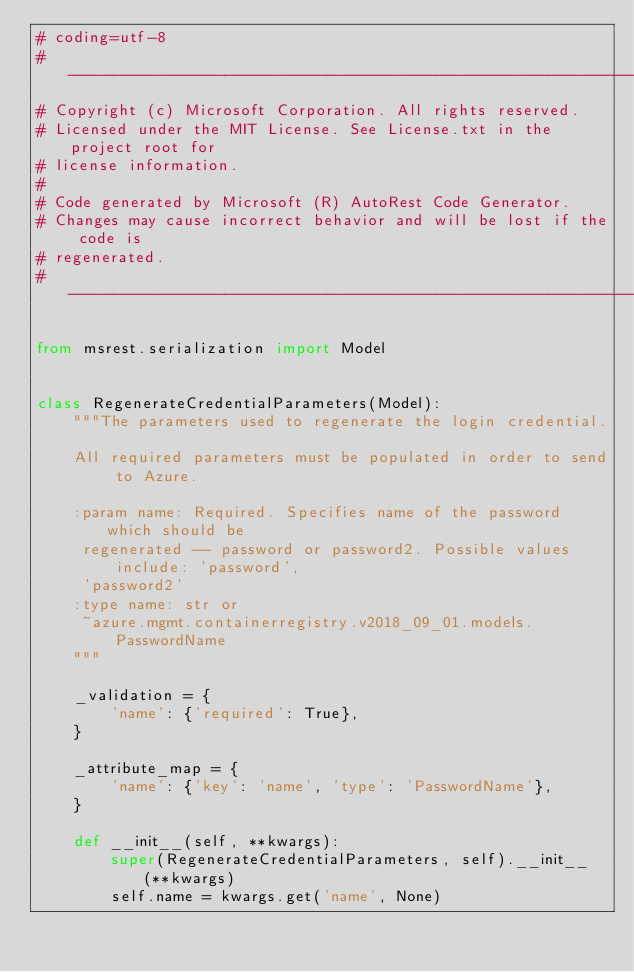<code> <loc_0><loc_0><loc_500><loc_500><_Python_># coding=utf-8
# --------------------------------------------------------------------------
# Copyright (c) Microsoft Corporation. All rights reserved.
# Licensed under the MIT License. See License.txt in the project root for
# license information.
#
# Code generated by Microsoft (R) AutoRest Code Generator.
# Changes may cause incorrect behavior and will be lost if the code is
# regenerated.
# --------------------------------------------------------------------------

from msrest.serialization import Model


class RegenerateCredentialParameters(Model):
    """The parameters used to regenerate the login credential.

    All required parameters must be populated in order to send to Azure.

    :param name: Required. Specifies name of the password which should be
     regenerated -- password or password2. Possible values include: 'password',
     'password2'
    :type name: str or
     ~azure.mgmt.containerregistry.v2018_09_01.models.PasswordName
    """

    _validation = {
        'name': {'required': True},
    }

    _attribute_map = {
        'name': {'key': 'name', 'type': 'PasswordName'},
    }

    def __init__(self, **kwargs):
        super(RegenerateCredentialParameters, self).__init__(**kwargs)
        self.name = kwargs.get('name', None)
</code> 